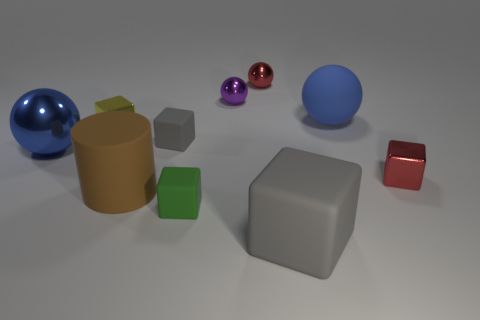Is there anything else that has the same shape as the big shiny object?
Provide a short and direct response. Yes. Is the tiny green object made of the same material as the small block right of the tiny purple ball?
Offer a very short reply. No. There is a small object that is to the left of the big brown cylinder; does it have the same color as the big matte cylinder?
Your response must be concise. No. What number of tiny objects are both behind the tiny green thing and in front of the big brown cylinder?
Your answer should be compact. 0. How many other things are the same material as the red sphere?
Your answer should be very brief. 4. Does the big sphere that is in front of the blue rubber sphere have the same material as the tiny red cube?
Ensure brevity in your answer.  Yes. There is a rubber block left of the small matte object that is in front of the metallic thing that is right of the big blue rubber ball; what is its size?
Ensure brevity in your answer.  Small. How many other objects are there of the same color as the big metallic sphere?
Offer a terse response. 1. What is the shape of the blue object that is the same size as the blue metallic sphere?
Keep it short and to the point. Sphere. How big is the gray matte cube that is in front of the tiny green matte block?
Your response must be concise. Large. 